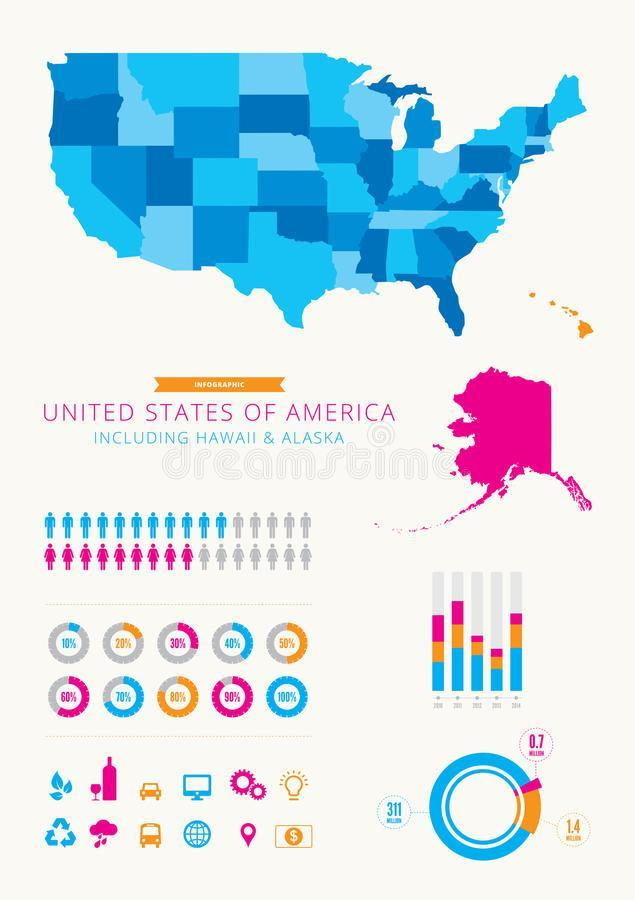In which color Hawaii is shown in the map- red, orange, green, blue?
Answer the question with a short phrase. orange What is the color given to the United states- white, red, blue, orange? blue In which year Alaska population is the highest? 2010 In the given info graphic how many men are coloured in blue? 11 In which year United states has the lowest population? 2013 In which color Alaska is shown in the map- yellow, magenta, blue, green? magenta In the given info graphic how many women are coloured in magenta? 9 